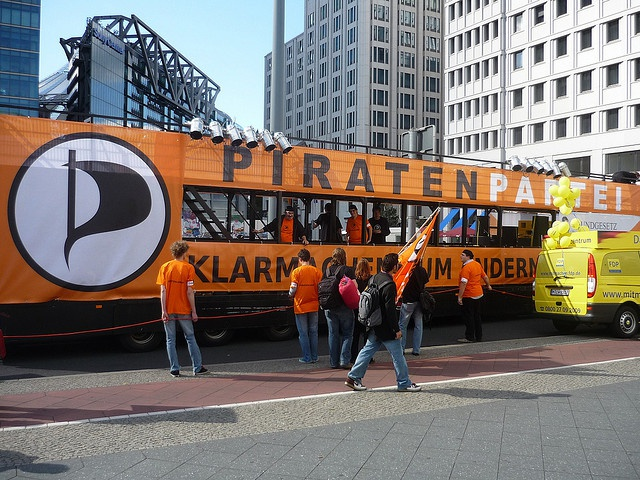Describe the objects in this image and their specific colors. I can see bus in blue, black, brown, orange, and darkgray tones, truck in blue, khaki, black, olive, and gold tones, people in blue, black, gray, and darkblue tones, people in blue, brown, gray, and black tones, and people in blue, black, gray, maroon, and navy tones in this image. 